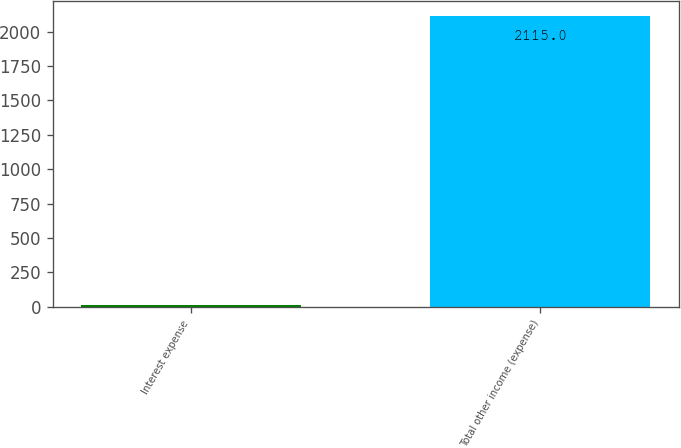<chart> <loc_0><loc_0><loc_500><loc_500><bar_chart><fcel>Interest expense<fcel>Total other income (expense)<nl><fcel>16<fcel>2115<nl></chart> 